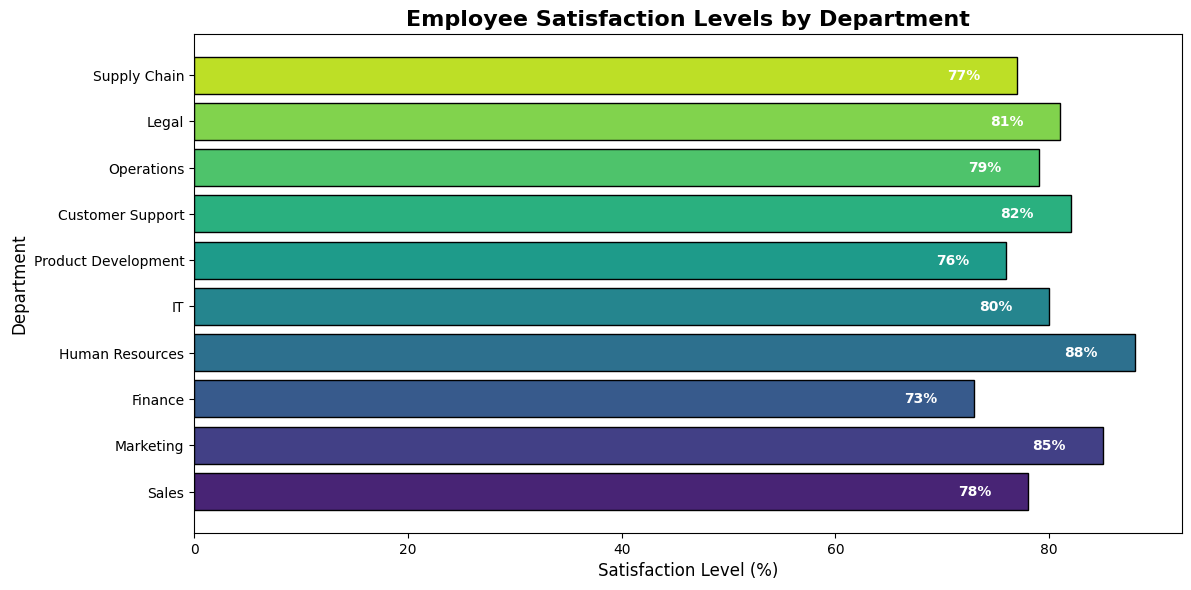Which department has the highest employee satisfaction level? According to the bar chart, among all the departments, Human Resources has the highest satisfaction level. It is shown by the highest bar on the horizontal axis at 88%.
Answer: Human Resources Which department has the lowest employee satisfaction level? By observing the bar lengths on the chart, the Finance department has the lowest satisfaction level with 73%.
Answer: Finance What is the average satisfaction level across all departments? The satisfaction levels are given as 78, 85, 73, 88, 80, 76, 82, 79, 81, 77. Summing these values yields 799. Dividing by the number of departments (10), the average satisfaction level is 799/10 = 79.9%.
Answer: 79.9% How much higher is the satisfaction level in Marketing compared to Product Development? The satisfaction level for Marketing is 85% and for Product Development is 76%. The difference is calculated as 85 - 76 = 9%.
Answer: 9% Does the IT department have higher satisfaction than Operations? The satisfaction levels are 80% for IT and 79% for Operations. Since 80% is greater than 79%, IT has higher satisfaction than Operations.
Answer: Yes How many departments have a satisfaction level above 80%? The departments with satisfaction levels above 80% are Marketing (85%), Human Resources (88%), IT (80%), Customer Support (82%), and Legal (81%). Counting these, we have 5 departments.
Answer: 5 What's the difference between the highest and lowest satisfaction levels? The highest and lowest satisfaction levels are 88% (Human Resources) and 73% (Finance), respectively. The difference is 88 - 73 = 15%.
Answer: 15% Which departments have a satisfaction level within 5% of the average satisfaction level? The average satisfaction level is 79.9%. Departments within 5% of this average have satisfaction levels between 74.9% and 84.9%. The eligible departments are Sales (78%), Marketing (85%), IT (80%), Product Development (76%), Customer Support (82%), Operations (79%), Legal (81%), and Supply Chain (77%).
Answer: Sales, IT, Product Development, Customer Support, Operations, Legal, Supply Chain 